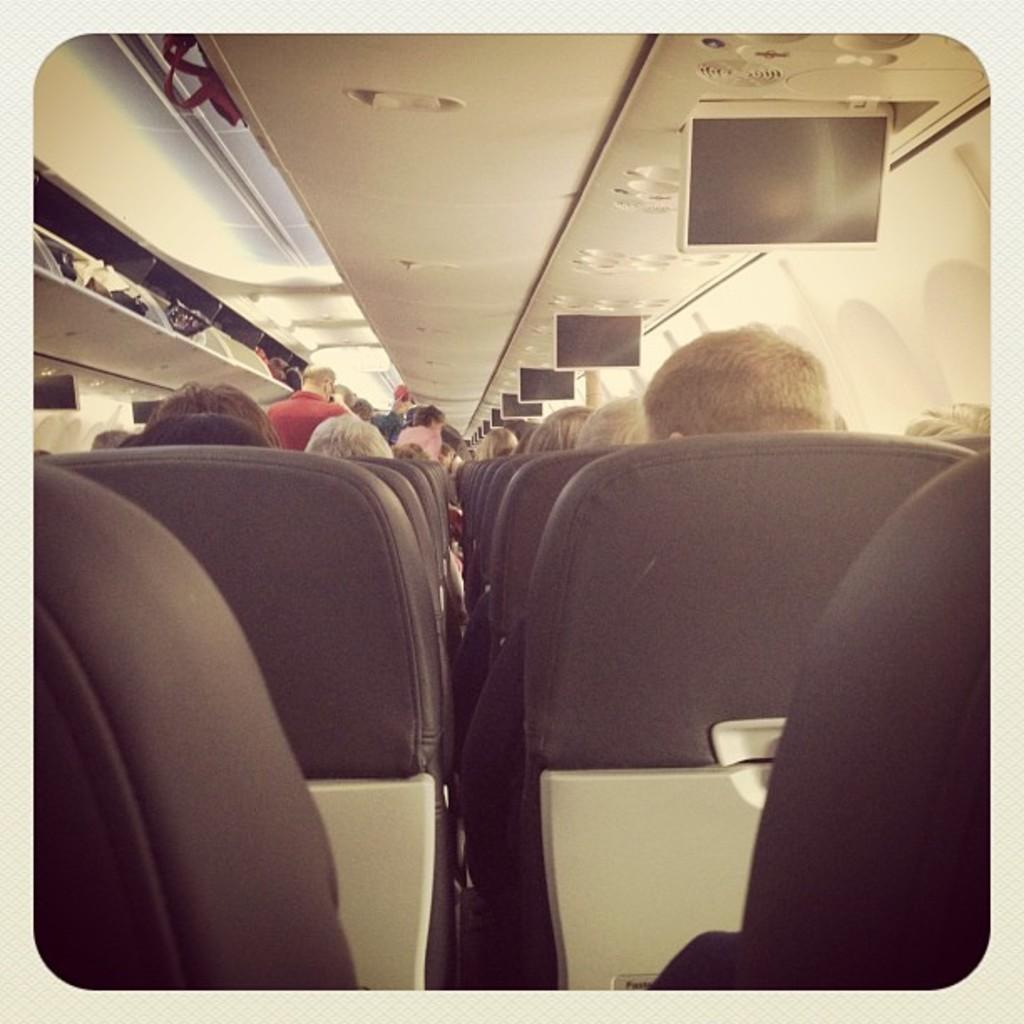Describe this image in one or two sentences. This is an edited picture. This is the picture of airplane. In this image there are group of people sitting and there are group of people standing. There are are bags at the top there are lights and screens. On the right side of the image there are windows. 